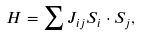<formula> <loc_0><loc_0><loc_500><loc_500>H = \sum J _ { i j } { S } _ { i } \cdot { S } _ { j } ,</formula> 